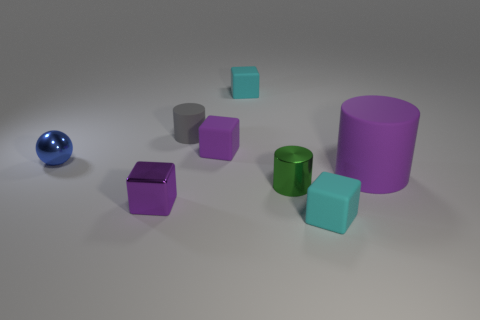What is the size of the purple cube that is behind the tiny purple cube that is left of the gray cylinder?
Your response must be concise. Small. There is a tiny object behind the gray rubber object; is its color the same as the small matte block in front of the blue sphere?
Provide a short and direct response. Yes. There is a tiny thing that is to the right of the gray object and behind the purple rubber block; what is its color?
Your response must be concise. Cyan. Do the tiny gray cylinder and the big purple cylinder have the same material?
Your answer should be compact. Yes. How many tiny objects are either gray matte objects or cyan blocks?
Provide a succinct answer. 3. Is there any other thing that is the same shape as the big rubber thing?
Your answer should be compact. Yes. Are there any other things that are the same size as the gray cylinder?
Give a very brief answer. Yes. There is a tiny cylinder that is made of the same material as the sphere; what is its color?
Keep it short and to the point. Green. What color is the rubber cylinder that is to the left of the large cylinder?
Give a very brief answer. Gray. How many small shiny objects are the same color as the large cylinder?
Provide a succinct answer. 1. 